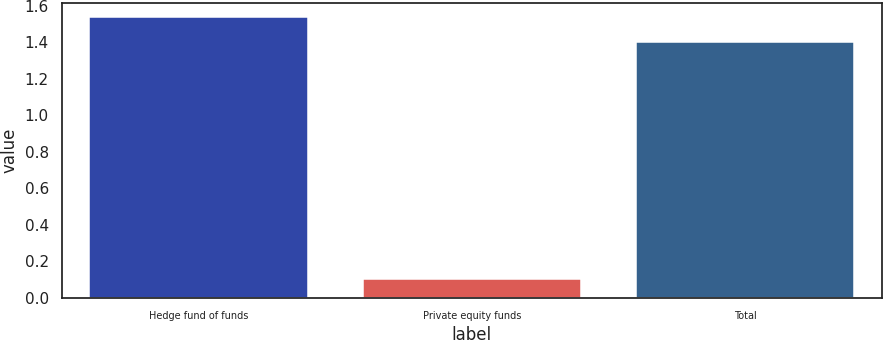<chart> <loc_0><loc_0><loc_500><loc_500><bar_chart><fcel>Hedge fund of funds<fcel>Private equity funds<fcel>Total<nl><fcel>1.54<fcel>0.1<fcel>1.4<nl></chart> 